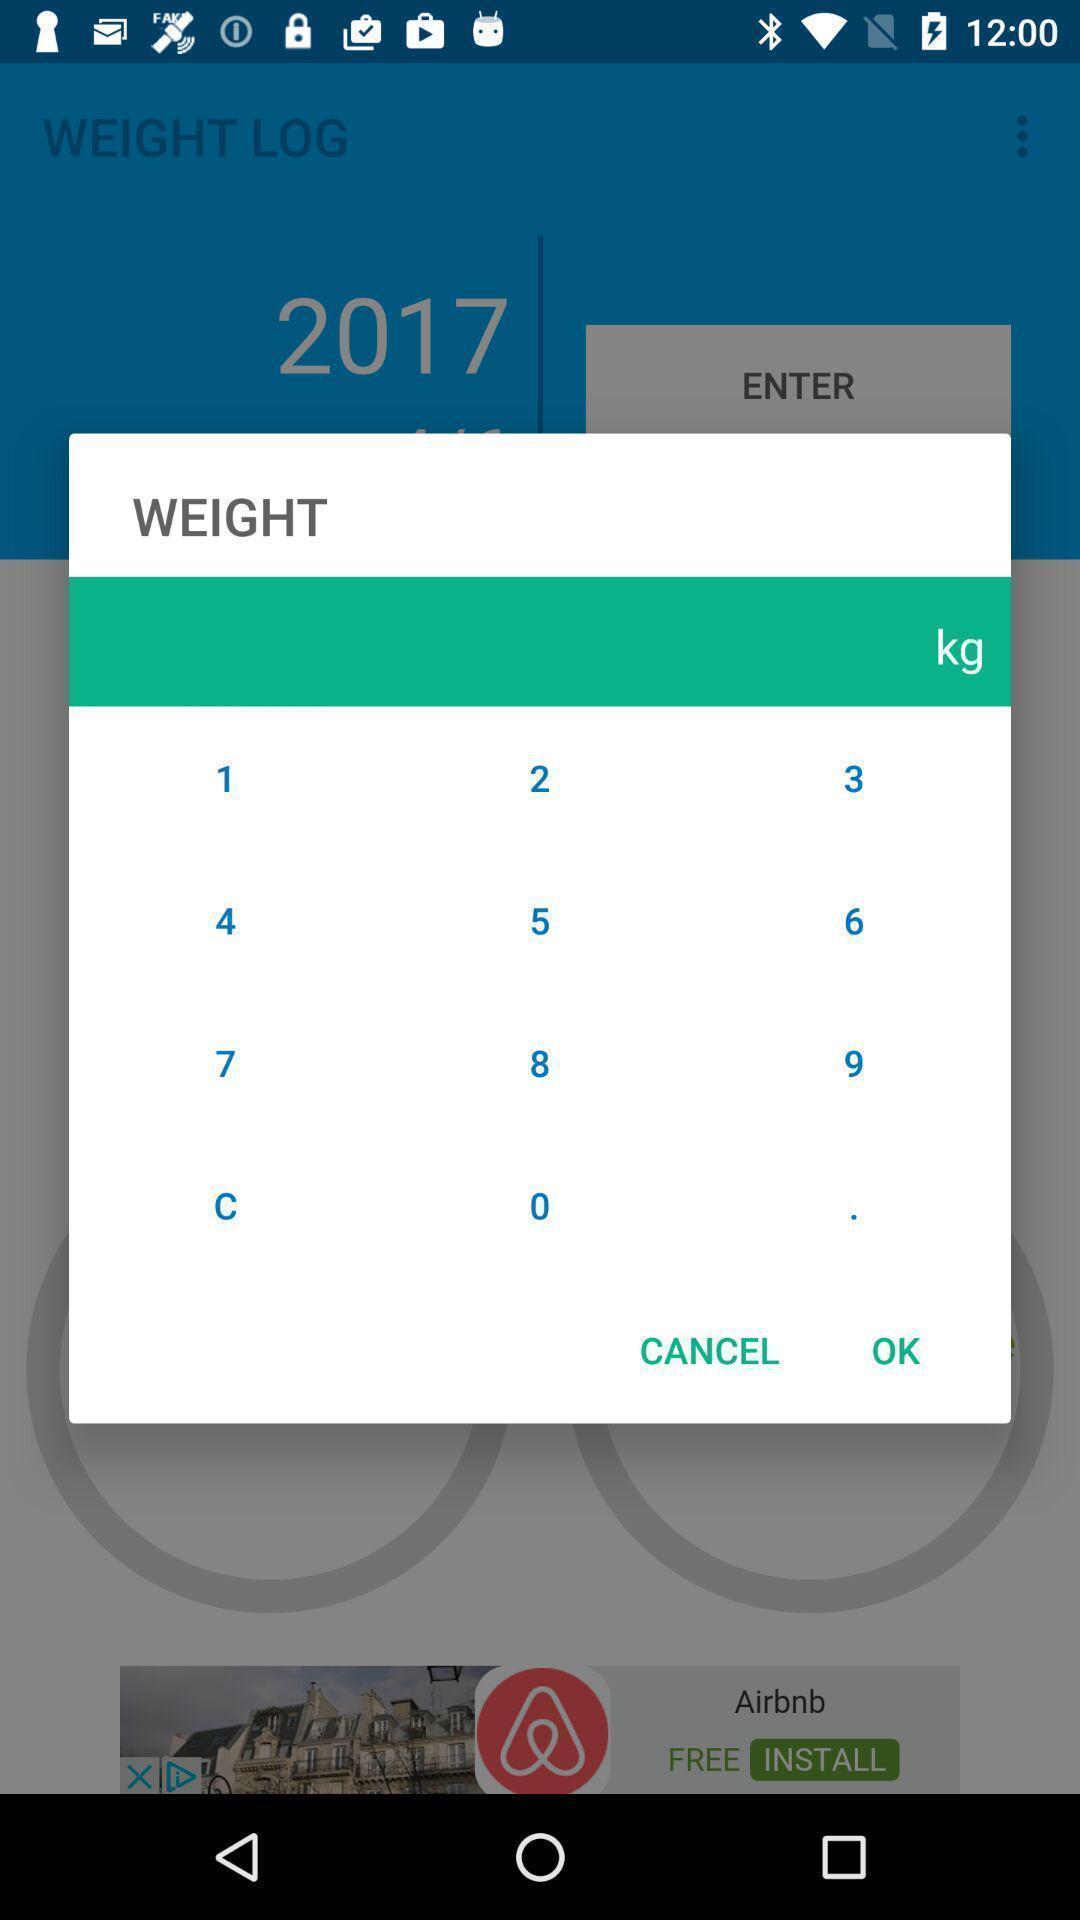Explain what's happening in this screen capture. Pop-up showing various numbers to select the weight. 